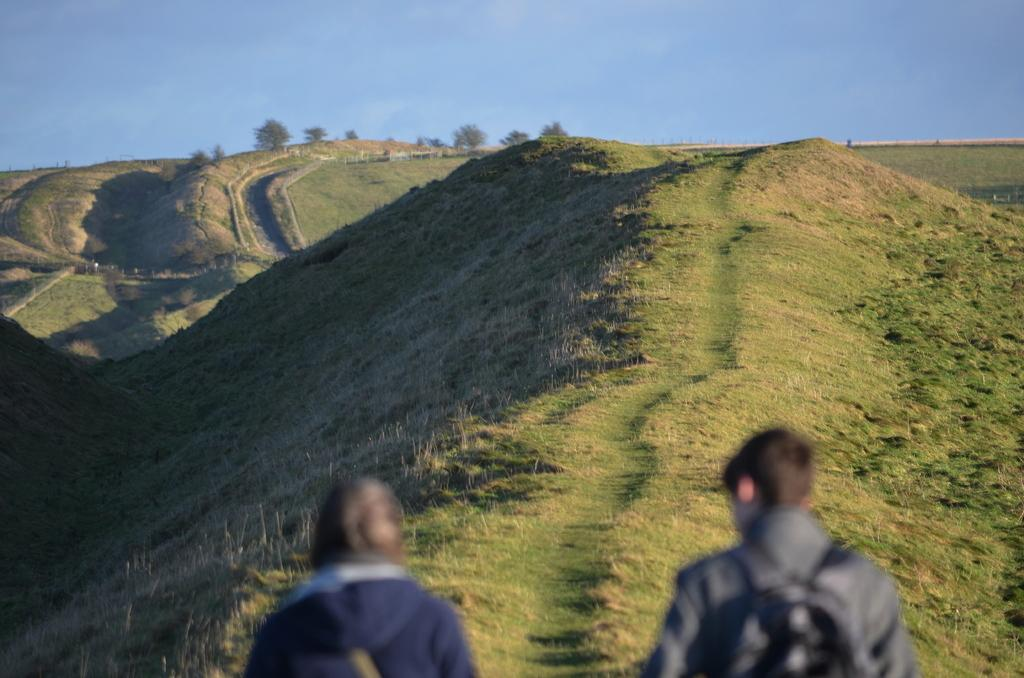How many people are present in the image? There are two people in the image. What can be seen in the background of the image? There is grass, trees, and the sky visible in the background of the image. What is the process of digestion for the trees in the image? The trees in the image do not have a digestive process, as they are plants and not animals. How many arms does the grass in the image have? Grass does not have arms, as it is a plant and not a human or animal. 